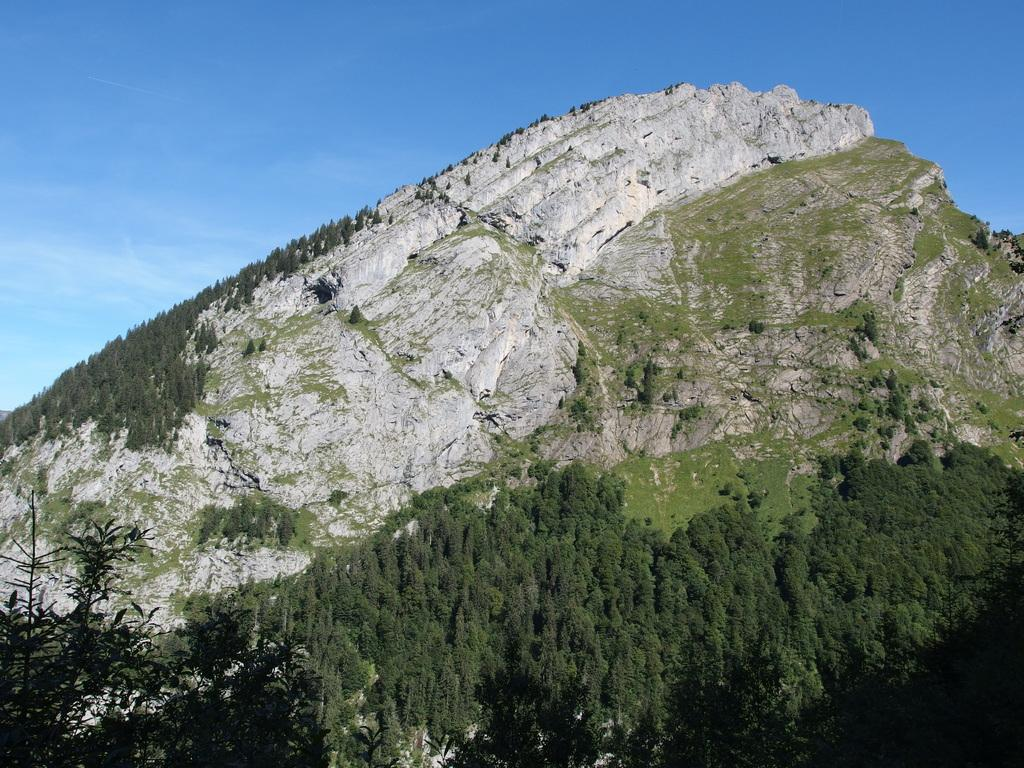What type of setting is depicted in the image? The image is an outside view. What can be seen on the hill in the image? There are trees on a hill in the image. What part of the trees is visible at the bottom of the image? There are branches at the bottom of the image. What is visible at the top of the image? The sky is visible at the top of the image. What type of transport is shown in the image? There is no transport visible in the image; it features an outside view with trees on a hill, branches, and the sky. What type of structure is present in the image? There is no structure present in the image; it features an outside view with trees on a hill, branches, and the sky. 